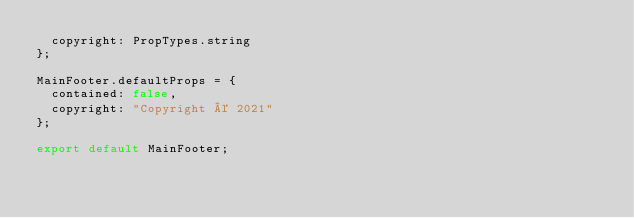<code> <loc_0><loc_0><loc_500><loc_500><_JavaScript_>  copyright: PropTypes.string
};

MainFooter.defaultProps = {
  contained: false,
  copyright: "Copyright © 2021"
};

export default MainFooter;
</code> 